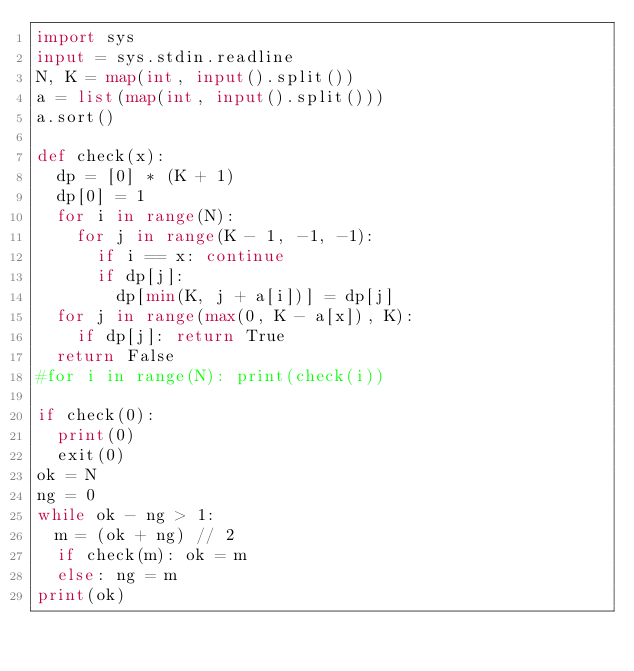Convert code to text. <code><loc_0><loc_0><loc_500><loc_500><_Python_>import sys
input = sys.stdin.readline
N, K = map(int, input().split())
a = list(map(int, input().split()))
a.sort()

def check(x):
  dp = [0] * (K + 1)
  dp[0] = 1
  for i in range(N):
    for j in range(K - 1, -1, -1):
      if i == x: continue
      if dp[j]:
        dp[min(K, j + a[i])] = dp[j]
  for j in range(max(0, K - a[x]), K):
    if dp[j]: return True
  return False
#for i in range(N): print(check(i))

if check(0):
  print(0)
  exit(0)
ok = N
ng = 0
while ok - ng > 1:
  m = (ok + ng) // 2
  if check(m): ok = m
  else: ng = m
print(ok)
</code> 